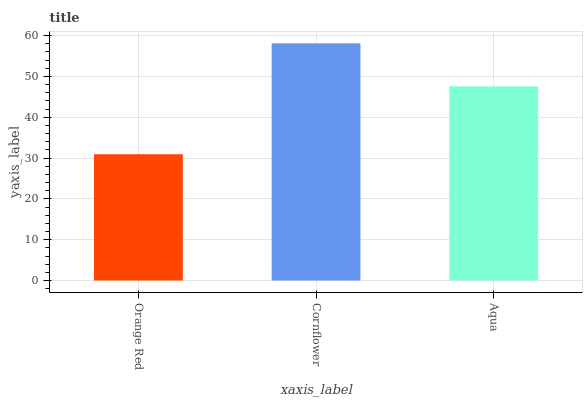Is Aqua the minimum?
Answer yes or no. No. Is Aqua the maximum?
Answer yes or no. No. Is Cornflower greater than Aqua?
Answer yes or no. Yes. Is Aqua less than Cornflower?
Answer yes or no. Yes. Is Aqua greater than Cornflower?
Answer yes or no. No. Is Cornflower less than Aqua?
Answer yes or no. No. Is Aqua the high median?
Answer yes or no. Yes. Is Aqua the low median?
Answer yes or no. Yes. Is Orange Red the high median?
Answer yes or no. No. Is Cornflower the low median?
Answer yes or no. No. 